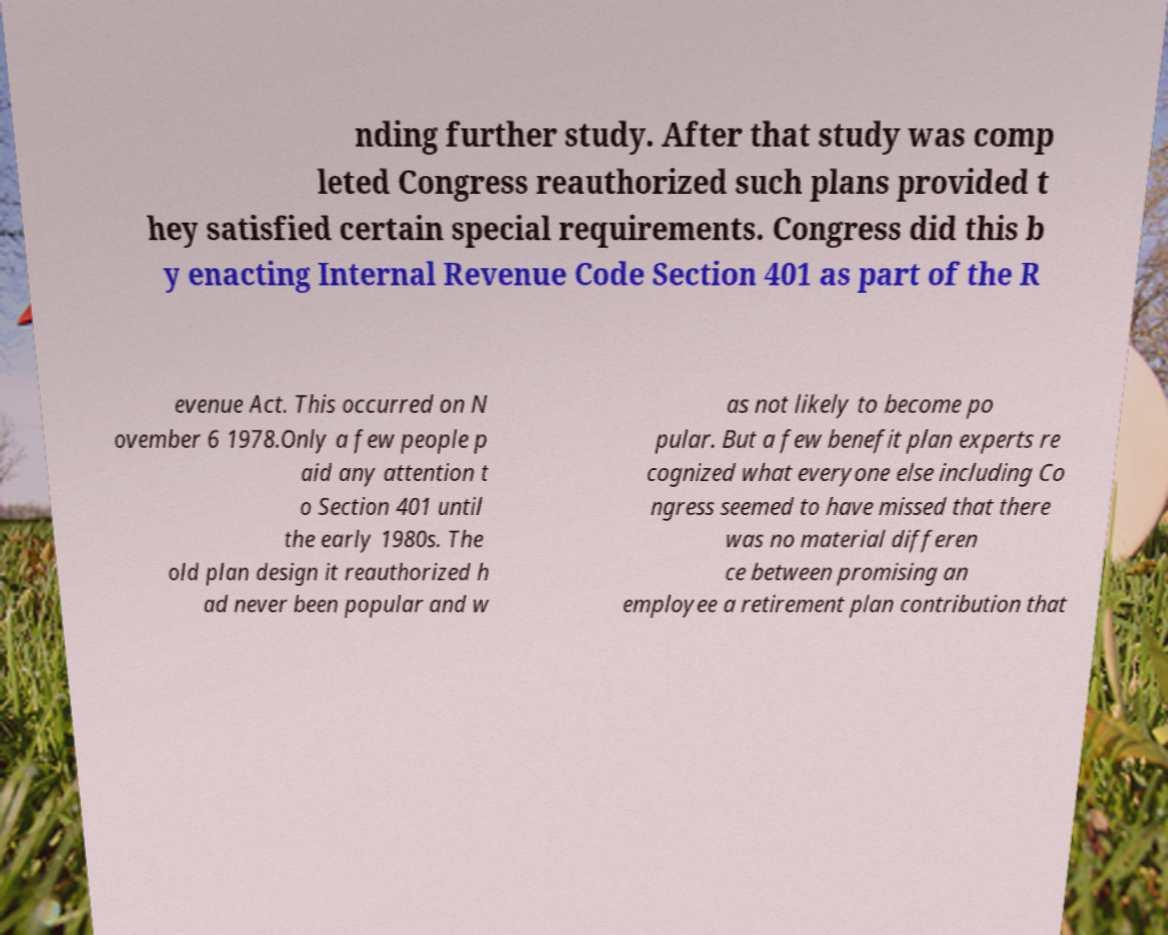Can you accurately transcribe the text from the provided image for me? nding further study. After that study was comp leted Congress reauthorized such plans provided t hey satisfied certain special requirements. Congress did this b y enacting Internal Revenue Code Section 401 as part of the R evenue Act. This occurred on N ovember 6 1978.Only a few people p aid any attention t o Section 401 until the early 1980s. The old plan design it reauthorized h ad never been popular and w as not likely to become po pular. But a few benefit plan experts re cognized what everyone else including Co ngress seemed to have missed that there was no material differen ce between promising an employee a retirement plan contribution that 